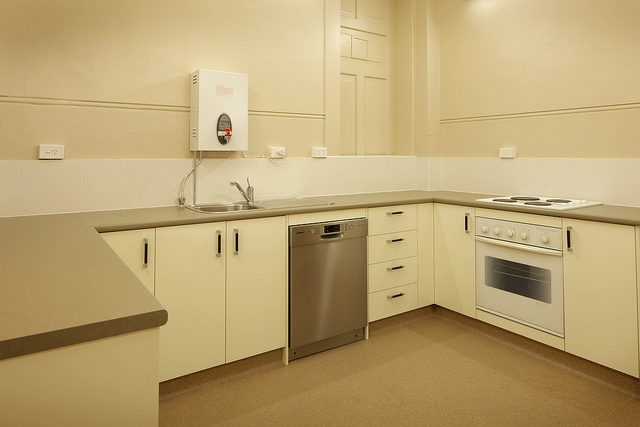Describe the objects in this image and their specific colors. I can see oven in tan tones and sink in tan and olive tones in this image. 